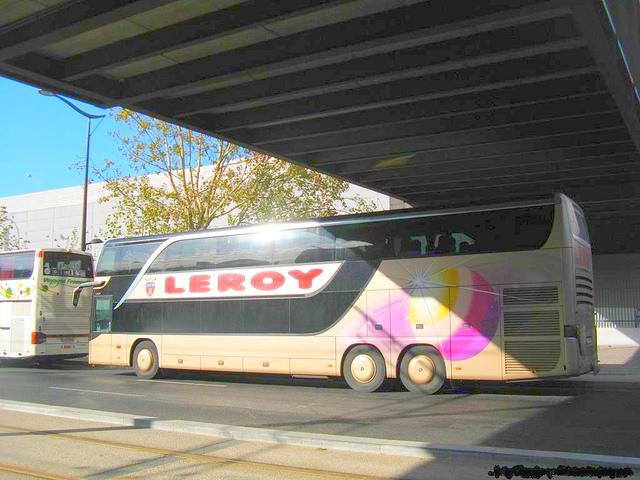Is the bus all white?
Answer briefly. No. What does the print on the bus say?
Give a very brief answer. Leroy. What is the bus driving under?
Give a very brief answer. Bridge. 